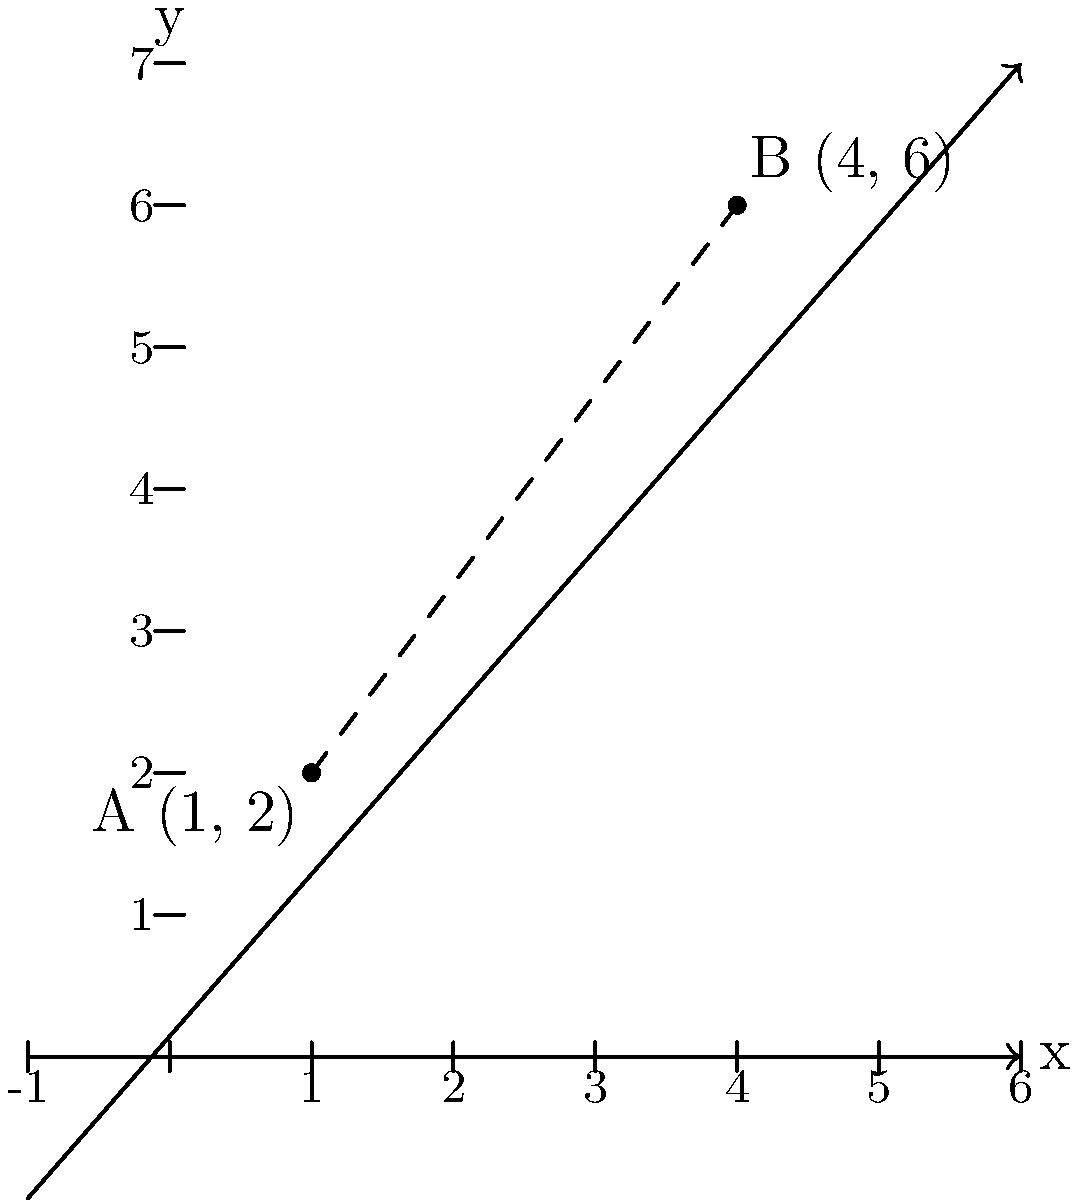In a monodominant coniferous forest, two Douglas fir trees are located at points A(1, 2) and B(4, 6) on a coordinate plane, where each unit represents 10 meters. What is the straight-line distance between these two trees in meters? To find the distance between two points on a coordinate plane, we can use the distance formula, which is derived from the Pythagorean theorem:

$$d = \sqrt{(x_2 - x_1)^2 + (y_2 - y_1)^2}$$

Where $(x_1, y_1)$ are the coordinates of the first point and $(x_2, y_2)$ are the coordinates of the second point.

Let's solve this step-by-step:

1) We have A(1, 2) and B(4, 6), so:
   $x_1 = 1$, $y_1 = 2$
   $x_2 = 4$, $y_2 = 6$

2) Plug these into the formula:
   $$d = \sqrt{(4 - 1)^2 + (6 - 2)^2}$$

3) Simplify inside the parentheses:
   $$d = \sqrt{3^2 + 4^2}$$

4) Calculate the squares:
   $$d = \sqrt{9 + 16}$$

5) Add under the square root:
   $$d = \sqrt{25}$$

6) Simplify:
   $$d = 5$$

7) Remember that each unit represents 10 meters, so multiply by 10:
   $$d = 5 \times 10 = 50$$

Therefore, the distance between the two Douglas fir trees is 50 meters.
Answer: 50 meters 